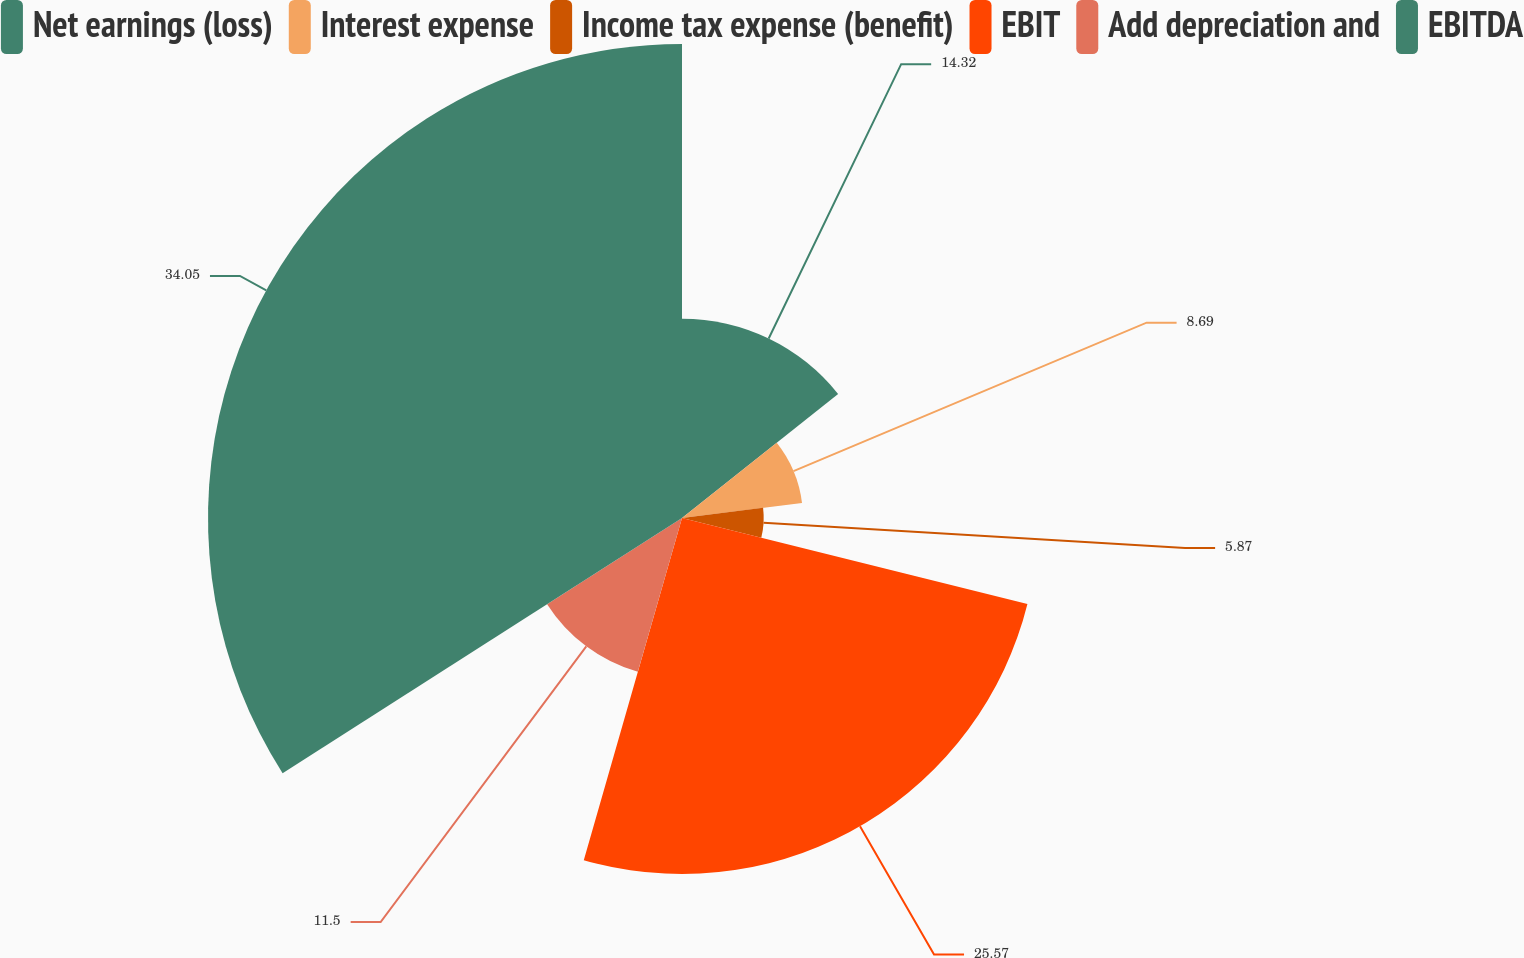Convert chart. <chart><loc_0><loc_0><loc_500><loc_500><pie_chart><fcel>Net earnings (loss)<fcel>Interest expense<fcel>Income tax expense (benefit)<fcel>EBIT<fcel>Add depreciation and<fcel>EBITDA<nl><fcel>14.32%<fcel>8.69%<fcel>5.87%<fcel>25.57%<fcel>11.5%<fcel>34.05%<nl></chart> 